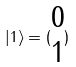<formula> <loc_0><loc_0><loc_500><loc_500>| 1 \rangle = ( \begin{matrix} 0 \\ 1 \end{matrix} )</formula> 